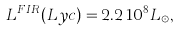<formula> <loc_0><loc_0><loc_500><loc_500>L ^ { F I R } ( L y c ) = 2 . 2 \, 1 0 ^ { 8 } L _ { \odot } ,</formula> 